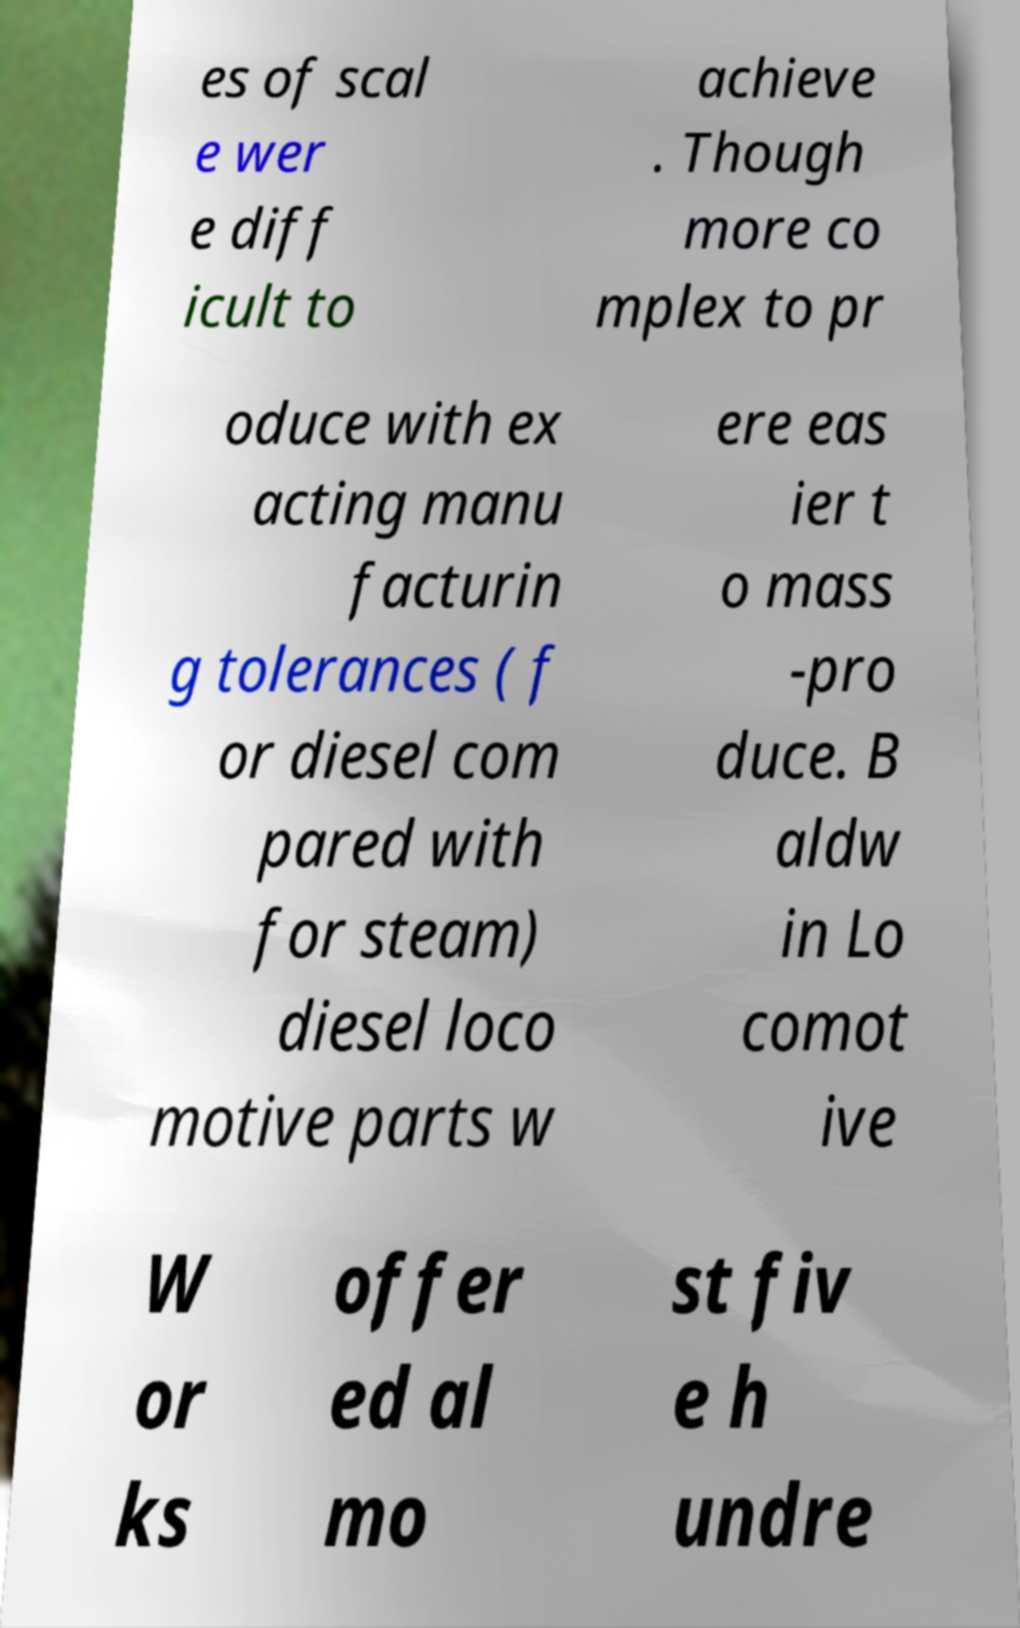I need the written content from this picture converted into text. Can you do that? es of scal e wer e diff icult to achieve . Though more co mplex to pr oduce with ex acting manu facturin g tolerances ( f or diesel com pared with for steam) diesel loco motive parts w ere eas ier t o mass -pro duce. B aldw in Lo comot ive W or ks offer ed al mo st fiv e h undre 